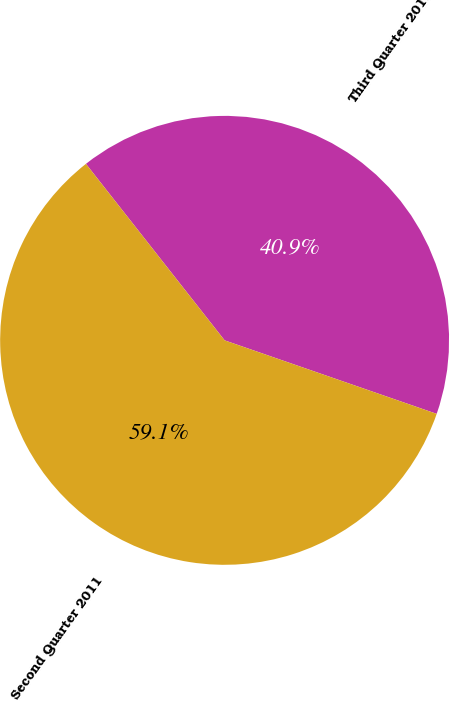<chart> <loc_0><loc_0><loc_500><loc_500><pie_chart><fcel>Third Quarter 2011<fcel>Second Quarter 2011<nl><fcel>40.91%<fcel>59.09%<nl></chart> 